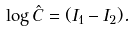Convert formula to latex. <formula><loc_0><loc_0><loc_500><loc_500>\log \hat { C } = ( I _ { 1 } - I _ { 2 } ) .</formula> 